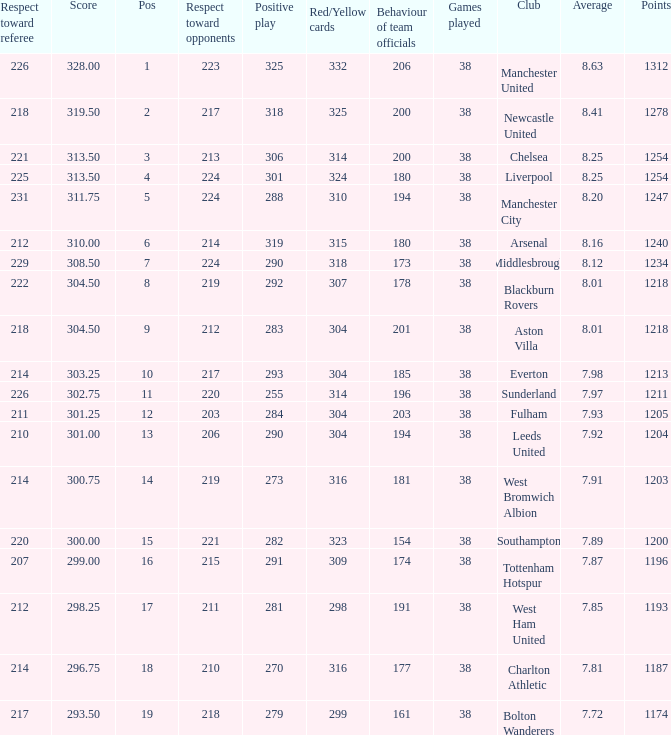Name the points for 212 respect toward opponents 1218.0. 